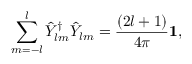Convert formula to latex. <formula><loc_0><loc_0><loc_500><loc_500>\sum _ { m = - l } ^ { l } \hat { Y } _ { l m } ^ { \dag } \hat { Y } _ { l m } = { \frac { ( 2 l + 1 ) } { 4 \pi } } { 1 } ,</formula> 